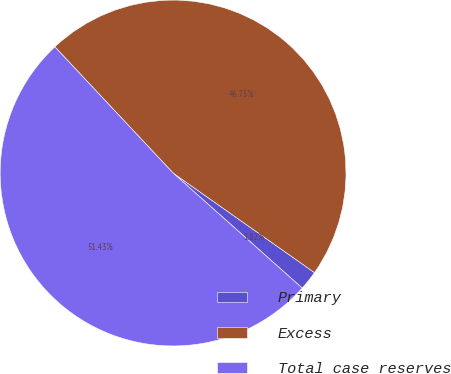Convert chart. <chart><loc_0><loc_0><loc_500><loc_500><pie_chart><fcel>Primary<fcel>Excess<fcel>Total case reserves<nl><fcel>1.82%<fcel>46.75%<fcel>51.43%<nl></chart> 